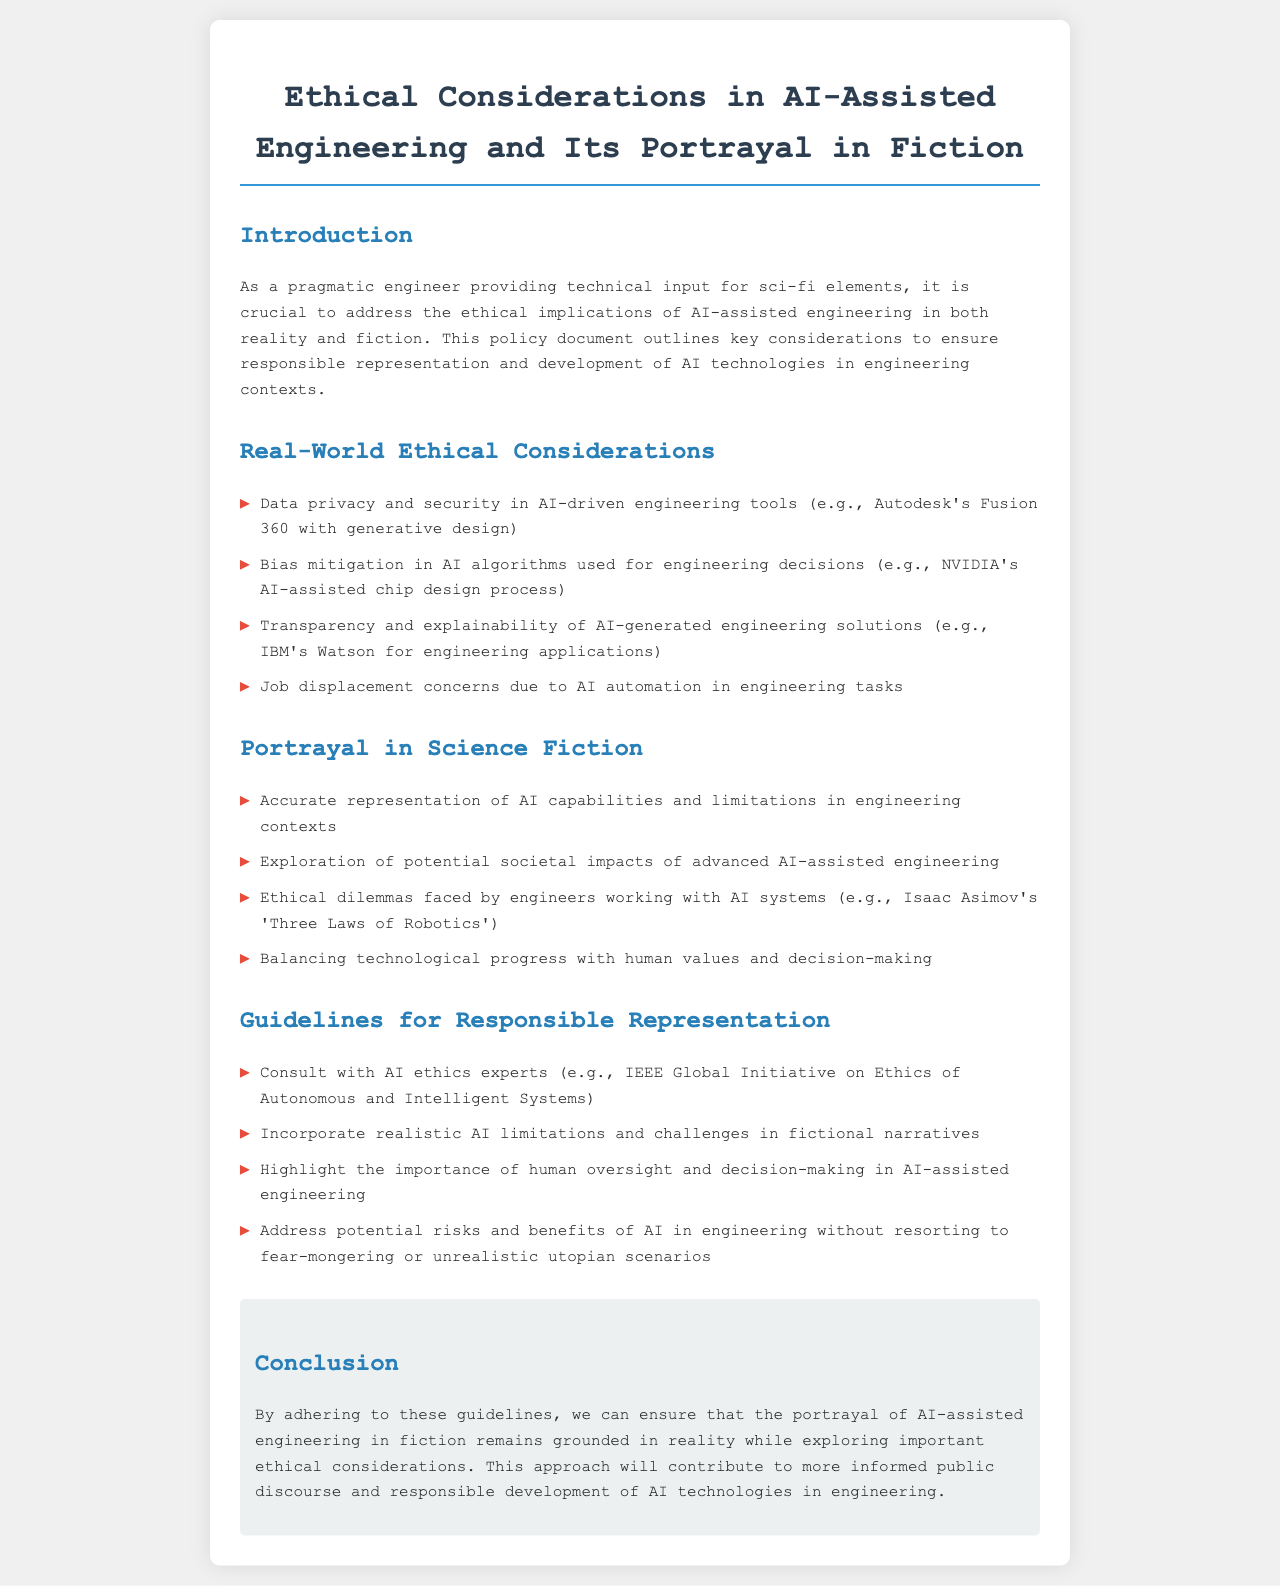What is the title of the document? The title is stated in the header of the document.
Answer: Ethical Considerations in AI-Assisted Engineering and Its Portrayal in Fiction How many ethical considerations are listed in the Real-World section? The number of items in the listed ethical considerations can be counted in the document.
Answer: 4 What is one example of a tool mentioned in the Real-World Ethical Considerations? The document provides an example of an engineering tool within the context of AI.
Answer: Autodesk's Fusion 360 Which sci-fi author is referenced in the Portrayal section? The document mentions a specific author known for their contributions to sci-fi narratives involving ethics in AI.
Answer: Isaac Asimov What is a guideline suggested for responsible representation? The document outlines recommended actions for representing AI in fiction.
Answer: Consult with AI ethics experts Why is transparency in AI-generated solutions important? The document indirectly emphasizes why transparency matters in engineering solutions driven by AI technologies.
Answer: Ethical considerations What is one potential risk of AI automation mentioned? The document identifies concerns related to the impact of AI on employment in engineering.
Answer: Job displacement What should narratives incorporate according to the Guidelines section? The document specifies what elements need to be included in fictional narratives to maintain realism.
Answer: Realistic AI limitations and challenges 